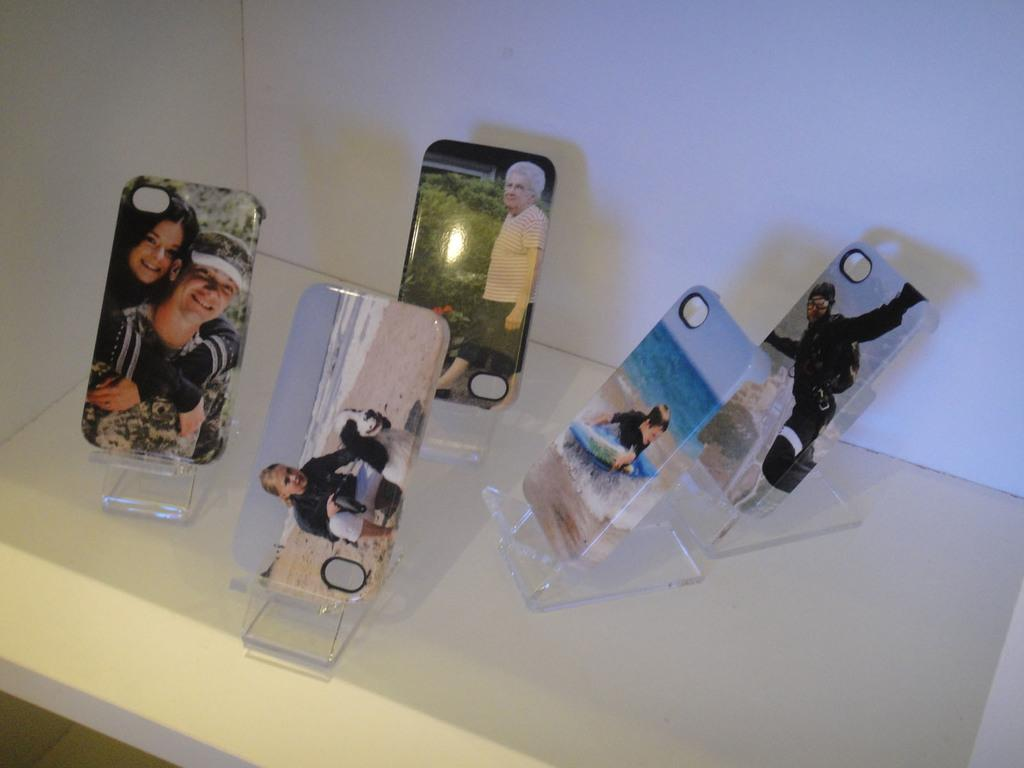What type of mobile accessories are visible in the image? There are mobile back cases with stands in the image. Where are the mobile back cases with stands located? The mobile back cases with stands are on a white platform. What can be seen in the background of the image? There is a wall in the image. What type of trouble does the record face in the image? There is no record present in the image, so it cannot face any trouble. 